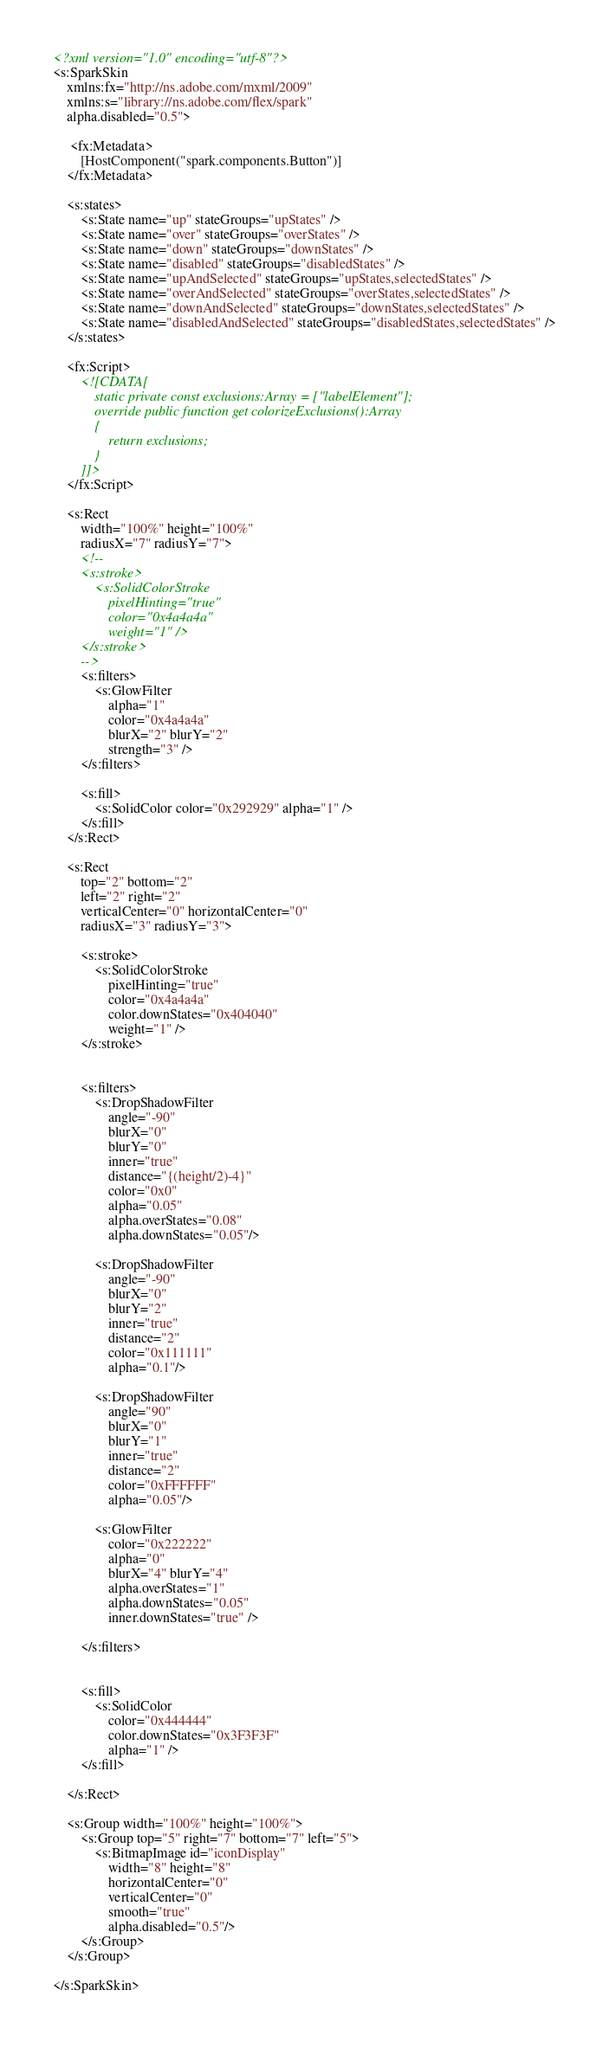<code> <loc_0><loc_0><loc_500><loc_500><_XML_><?xml version="1.0" encoding="utf-8"?>
<s:SparkSkin 
    xmlns:fx="http://ns.adobe.com/mxml/2009" 
    xmlns:s="library://ns.adobe.com/flex/spark"  
    alpha.disabled="0.5"> 
 
     <fx:Metadata> 
        [HostComponent("spark.components.Button")] 
    </fx:Metadata> 
  
    <s:states> 
        <s:State name="up" stateGroups="upStates" /> 
        <s:State name="over" stateGroups="overStates" /> 
        <s:State name="down" stateGroups="downStates" /> 
        <s:State name="disabled" stateGroups="disabledStates" />
		<s:State name="upAndSelected" stateGroups="upStates,selectedStates" />
		<s:State name="overAndSelected" stateGroups="overStates,selectedStates" />
		<s:State name="downAndSelected" stateGroups="downStates,selectedStates" />
		<s:State name="disabledAndSelected" stateGroups="disabledStates,selectedStates" />
	</s:states>  
 
 	<fx:Script> 
        <![CDATA[         
            static private const exclusions:Array = ["labelElement"]; 
            override public function get colorizeExclusions():Array
            {
            	return exclusions;
            } 
        ]]>        
    </fx:Script>
	
	<s:Rect 
		width="100%" height="100%"
		radiusX="7" radiusY="7">
		<!--
		<s:stroke>
			<s:SolidColorStroke
				pixelHinting="true"
				color="0x4a4a4a" 
				weight="1" />
		</s:stroke>
		-->
		<s:filters>
			<s:GlowFilter 
				alpha="1" 
				color="0x4a4a4a"
				blurX="2" blurY="2"
				strength="3" />
		</s:filters>
		
		<s:fill>
			<s:SolidColor color="0x292929" alpha="1" />
		</s:fill>
	</s:Rect>

	<s:Rect
		top="2" bottom="2"
		left="2" right="2"
		verticalCenter="0" horizontalCenter="0"
		radiusX="3" radiusY="3">
		
		<s:stroke>
			<s:SolidColorStroke
				pixelHinting="true"
				color="0x4a4a4a"
				color.downStates="0x404040"
				weight="1" />
		</s:stroke>
		
			
		<s:filters>
			<s:DropShadowFilter
				angle="-90"
				blurX="0"
				blurY="0"
				inner="true"
				distance="{(height/2)-4}"
				color="0x0"
				alpha="0.05"
				alpha.overStates="0.08"
				alpha.downStates="0.05"/>
			
			<s:DropShadowFilter
				angle="-90"
				blurX="0"
				blurY="2"
				inner="true"
				distance="2"
				color="0x111111"
				alpha="0.1"/>
				
			<s:DropShadowFilter
				angle="90"
				blurX="0"
				blurY="1"
				inner="true"
				distance="2"
				color="0xFFFFFF"
				alpha="0.05"/>
				
			<s:GlowFilter
				color="0x222222"
				alpha="0"
				blurX="4" blurY="4"
				alpha.overStates="1"
				alpha.downStates="0.05"
				inner.downStates="true" />
				
		</s:filters>
			
		
		<s:fill>
			<s:SolidColor 
				color="0x444444"
				color.downStates="0x3F3F3F" 
				alpha="1" />
		</s:fill>
		
	</s:Rect>

	<s:Group width="100%" height="100%">
		<s:Group top="5" right="7" bottom="7" left="5">
			<s:BitmapImage id="iconDisplay"
				width="8" height="8"
				horizontalCenter="0"
				verticalCenter="0"
				smooth="true"
				alpha.disabled="0.5"/>
		</s:Group>
	</s:Group>
 
</s:SparkSkin></code> 